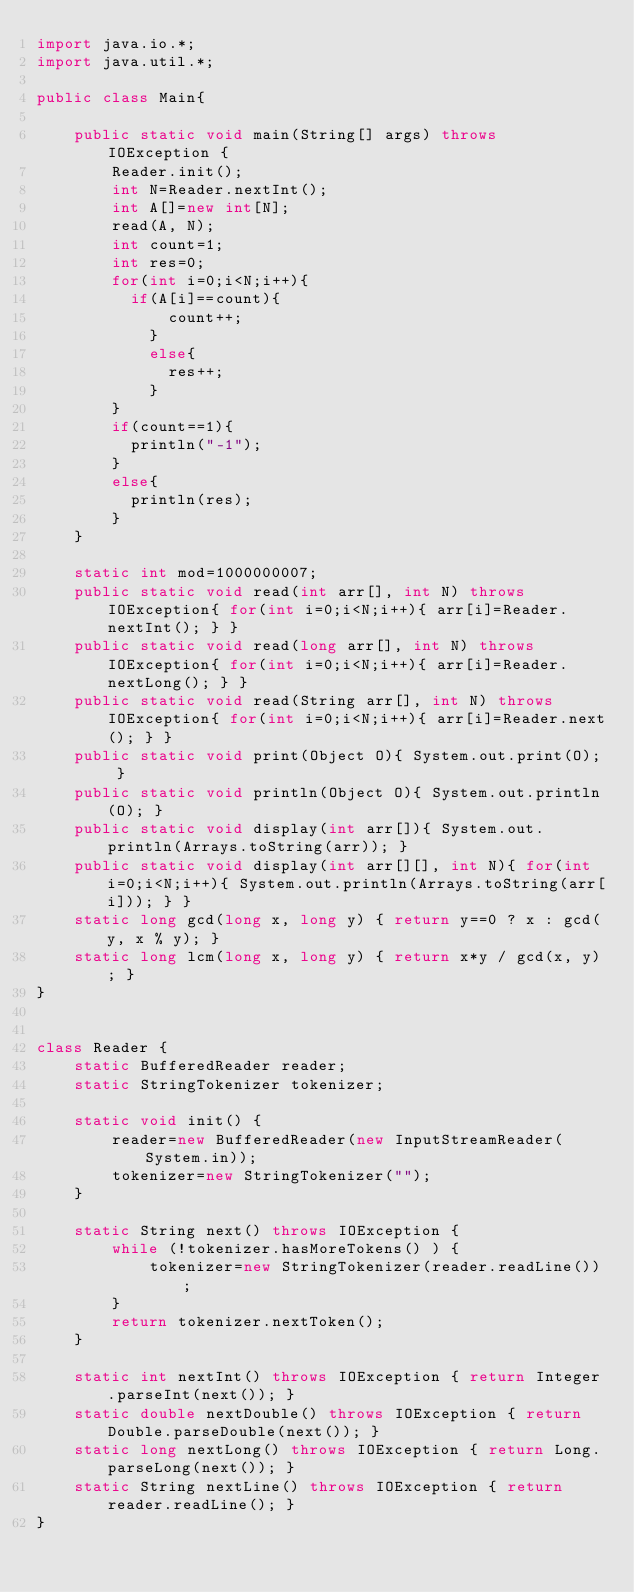<code> <loc_0><loc_0><loc_500><loc_500><_Java_>import java.io.*;
import java.util.*;

public class Main{

    public static void main(String[] args) throws IOException {
        Reader.init();
        int N=Reader.nextInt();
      	int A[]=new int[N];
      	read(A, N);
      	int count=1;
      	int res=0;
      	for(int i=0;i<N;i++){
        	if(A[i]==count){
            	count++;
            }
          	else{
            	res++;
            }
        }
      	if(count==1){
        	println("-1");
        }
      	else{
        	println(res);
        }
    }

    static int mod=1000000007;
    public static void read(int arr[], int N) throws IOException{ for(int i=0;i<N;i++){ arr[i]=Reader.nextInt(); } }
    public static void read(long arr[], int N) throws IOException{ for(int i=0;i<N;i++){ arr[i]=Reader.nextLong(); } }
    public static void read(String arr[], int N) throws IOException{ for(int i=0;i<N;i++){ arr[i]=Reader.next(); } }
    public static void print(Object O){ System.out.print(O); }
    public static void println(Object O){ System.out.println(O); }
    public static void display(int arr[]){ System.out.println(Arrays.toString(arr)); }
    public static void display(int arr[][], int N){ for(int i=0;i<N;i++){ System.out.println(Arrays.toString(arr[i])); } }
  	static long gcd(long x, long y) { return y==0 ? x : gcd(y, x % y); }
    static long lcm(long x, long y) { return x*y / gcd(x, y); }
}


class Reader {
    static BufferedReader reader;
    static StringTokenizer tokenizer;

    static void init() {
        reader=new BufferedReader(new InputStreamReader(System.in));
        tokenizer=new StringTokenizer("");
    }

    static String next() throws IOException {
        while (!tokenizer.hasMoreTokens() ) {
            tokenizer=new StringTokenizer(reader.readLine());
        }
        return tokenizer.nextToken();
    }

    static int nextInt() throws IOException { return Integer.parseInt(next()); }
    static double nextDouble() throws IOException { return Double.parseDouble(next()); }
    static long nextLong() throws IOException { return Long.parseLong(next()); }
    static String nextLine() throws IOException { return reader.readLine(); }
}</code> 